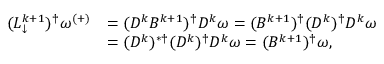<formula> <loc_0><loc_0><loc_500><loc_500>\begin{array} { r l } { ( L _ { \downarrow } ^ { k + 1 } ) ^ { \dagger } \omega ^ { ( + ) } } & { = ( D ^ { k } B ^ { k + 1 } ) ^ { \dagger } D ^ { k } \omega = ( B ^ { k + 1 } ) ^ { \dagger } ( D ^ { k } ) ^ { \dagger } D ^ { k } \omega } \\ & { = ( D ^ { k } ) ^ { * \dagger } ( D ^ { k } ) ^ { \dagger } D ^ { k } \omega = ( B ^ { k + 1 } ) ^ { \dagger } \omega , } \end{array}</formula> 